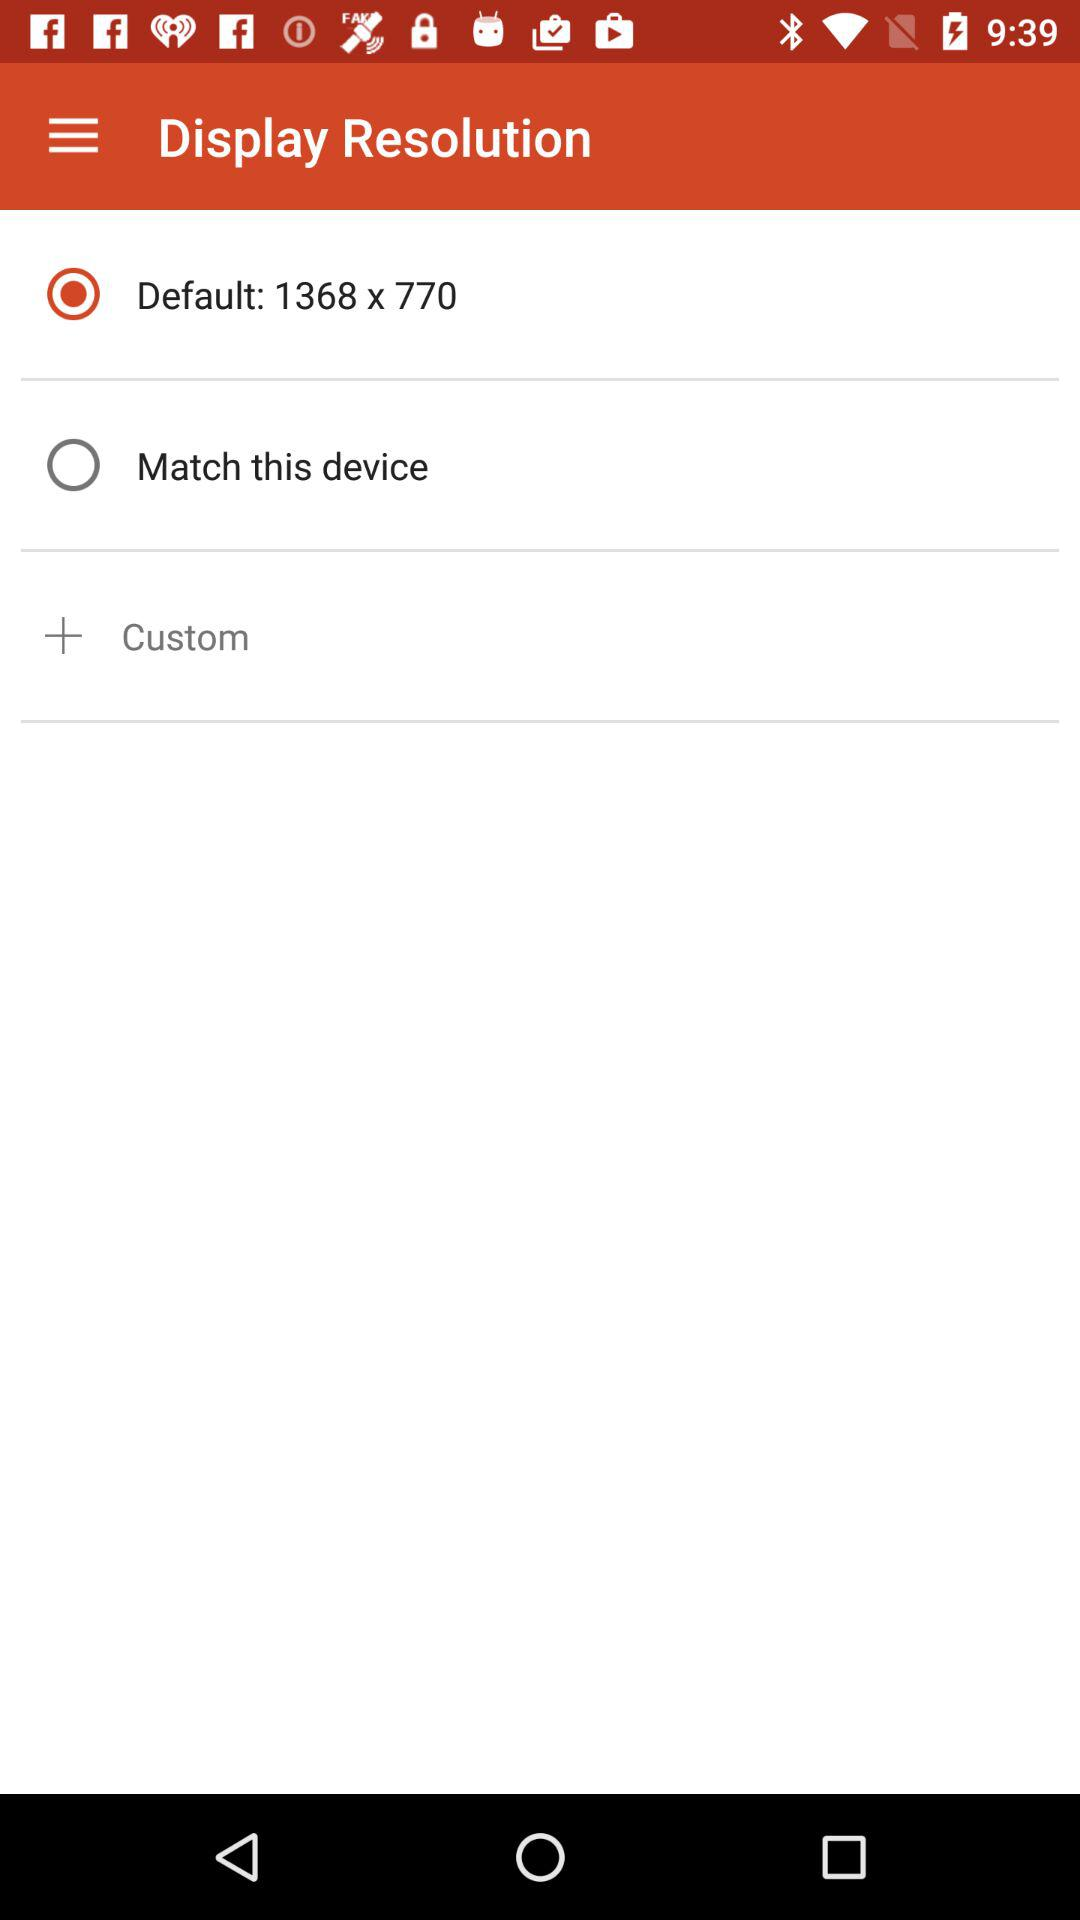Which option is selected? The selected option is "Default: 1368 x 770". 